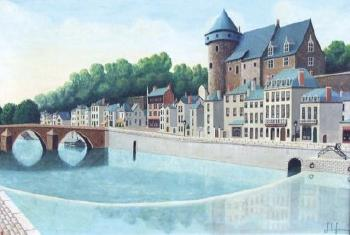Can you imagine what a day in this town might be like for a local resident? A day in this town for a local might start with a peaceful morning walk along the riverbanks, perhaps stopping at a small café for a coffee. The day could involve mingling in the town's market square, enjoying the local cuisine, and interacting with fellow residents. Evenings might be spent enjoying cultural activities or simply relaxing by the serene river, appreciating the historic charm and natural beauty surrounding them. What typical events or festivals might this town host? This town could host various cultural festivals, likely drawing on its historical and possibly medieval roots. These might include medieval reenactments, local art and craft fairs, food festivals celebrating regional specialties, and perhaps a seasonal festival centered around the river, including boat races or light displays on the water. 